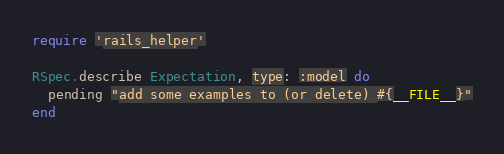Convert code to text. <code><loc_0><loc_0><loc_500><loc_500><_Ruby_>require 'rails_helper'

RSpec.describe Expectation, type: :model do
  pending "add some examples to (or delete) #{__FILE__}"
end
</code> 